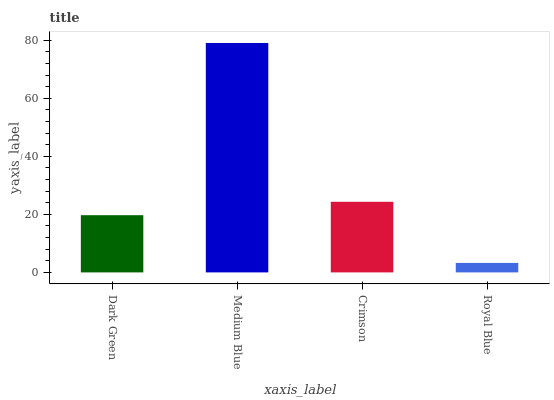Is Royal Blue the minimum?
Answer yes or no. Yes. Is Medium Blue the maximum?
Answer yes or no. Yes. Is Crimson the minimum?
Answer yes or no. No. Is Crimson the maximum?
Answer yes or no. No. Is Medium Blue greater than Crimson?
Answer yes or no. Yes. Is Crimson less than Medium Blue?
Answer yes or no. Yes. Is Crimson greater than Medium Blue?
Answer yes or no. No. Is Medium Blue less than Crimson?
Answer yes or no. No. Is Crimson the high median?
Answer yes or no. Yes. Is Dark Green the low median?
Answer yes or no. Yes. Is Dark Green the high median?
Answer yes or no. No. Is Crimson the low median?
Answer yes or no. No. 